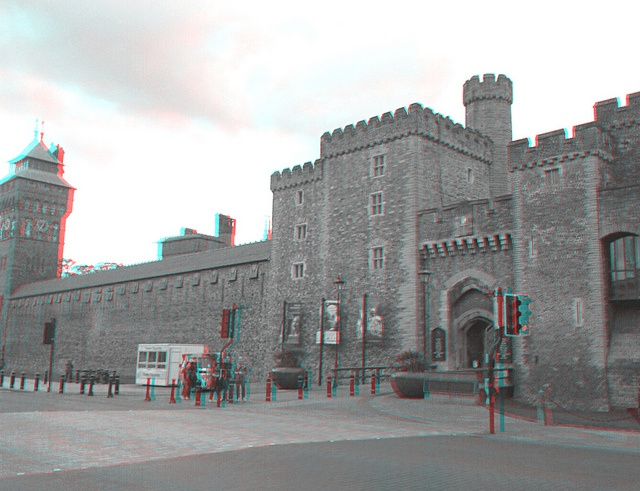Describe the objects in this image and their specific colors. I can see truck in lightgray, darkgray, gray, and lightblue tones, car in lightgray, gray, brown, darkgray, and teal tones, traffic light in lightgray, black, maroon, teal, and gray tones, people in lightgray, gray, brown, and teal tones, and traffic light in lightgray, maroon, teal, gray, and black tones in this image. 